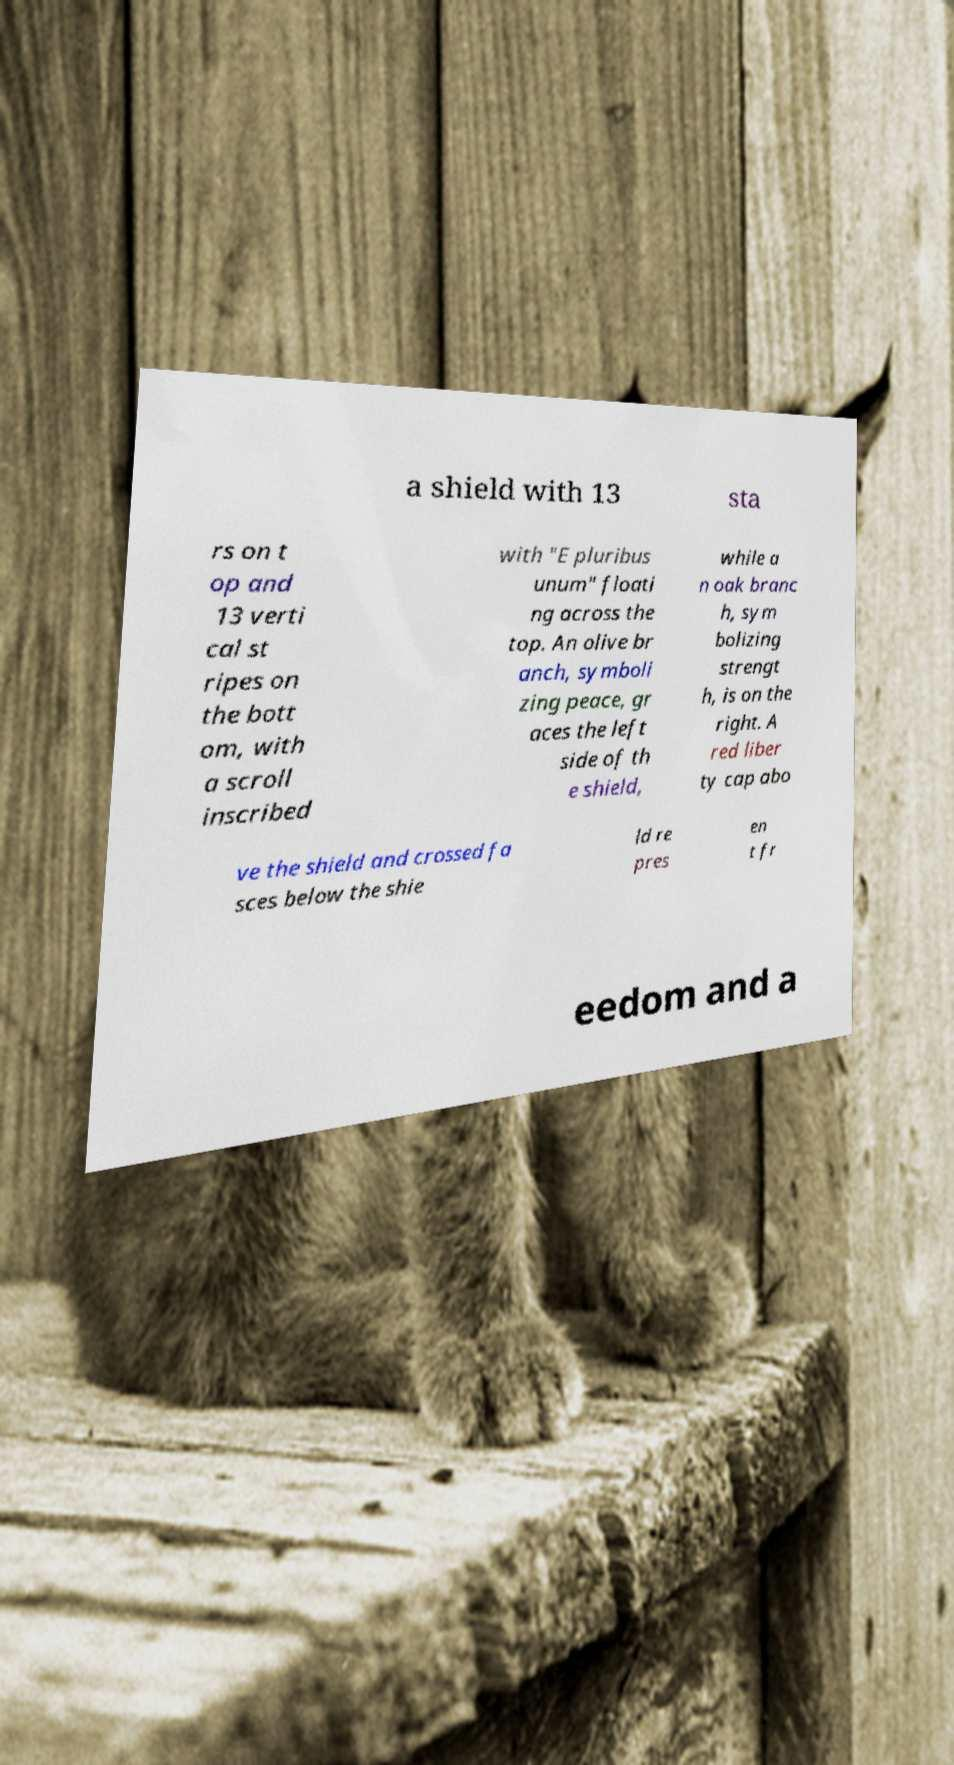There's text embedded in this image that I need extracted. Can you transcribe it verbatim? a shield with 13 sta rs on t op and 13 verti cal st ripes on the bott om, with a scroll inscribed with "E pluribus unum" floati ng across the top. An olive br anch, symboli zing peace, gr aces the left side of th e shield, while a n oak branc h, sym bolizing strengt h, is on the right. A red liber ty cap abo ve the shield and crossed fa sces below the shie ld re pres en t fr eedom and a 